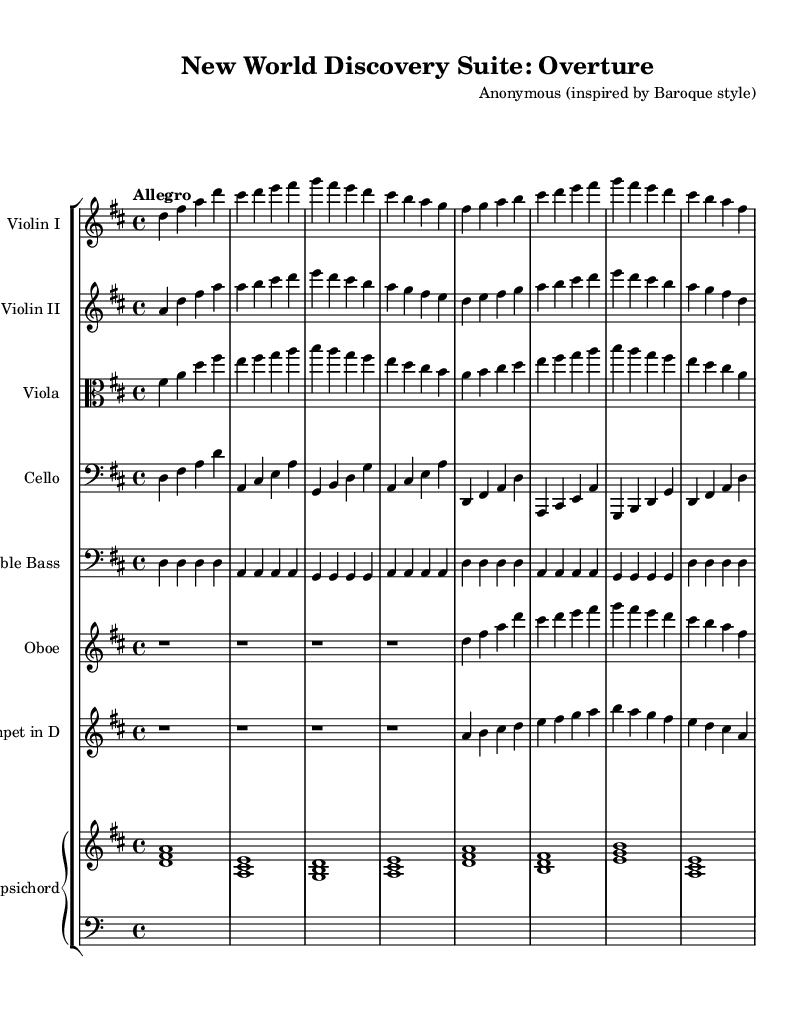What is the key signature of this music? The key signature is indicated by the number of sharps or flats in the music. In this piece, it is specified as "d" which indicates there are two sharps (F# and C#).
Answer: D major What is the time signature of this music? The time signature is found at the beginning of the score, right after the key signature. It is specified as "4/4," meaning there are four beats in each measure and a quarter note receives one beat.
Answer: 4/4 What is the tempo marking of this piece? The tempo marking is indicated in the score, and it is shown as "Allegro." This term suggests a fast and lively pace.
Answer: Allegro How many measures are there in the Overture? By counting the measures presented in the music, you can determine the total. The first line displays eight measures, and subsequent lines follow suit, eventually totaling twenty-four measures in the Overture.
Answer: Twenty-four What instruments are included in this orchestral suite? The instruments can be found at the beginning of each staff in the score. They include Violin I, Violin II, Viola, Cello, Double Bass, Oboe, Trumpet in D, and Harpsichord.
Answer: Violin I, Violin II, Viola, Cello, Double Bass, Oboe, Trumpet in D, Harpsichord What is the function of the harpsichord in this composition? The harpsichord serves as a continuo instrument, typically providing harmonic support. In the score, it plays chords indicated above the staff, allowing it to accompany the melodies.
Answer: Continuo 